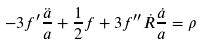Convert formula to latex. <formula><loc_0><loc_0><loc_500><loc_500>- 3 f ^ { \prime } \frac { \ddot { a } } { a } + \frac { 1 } { 2 } f + 3 f ^ { \prime \prime } \dot { R } \frac { \dot { a } } { a } = \rho</formula> 